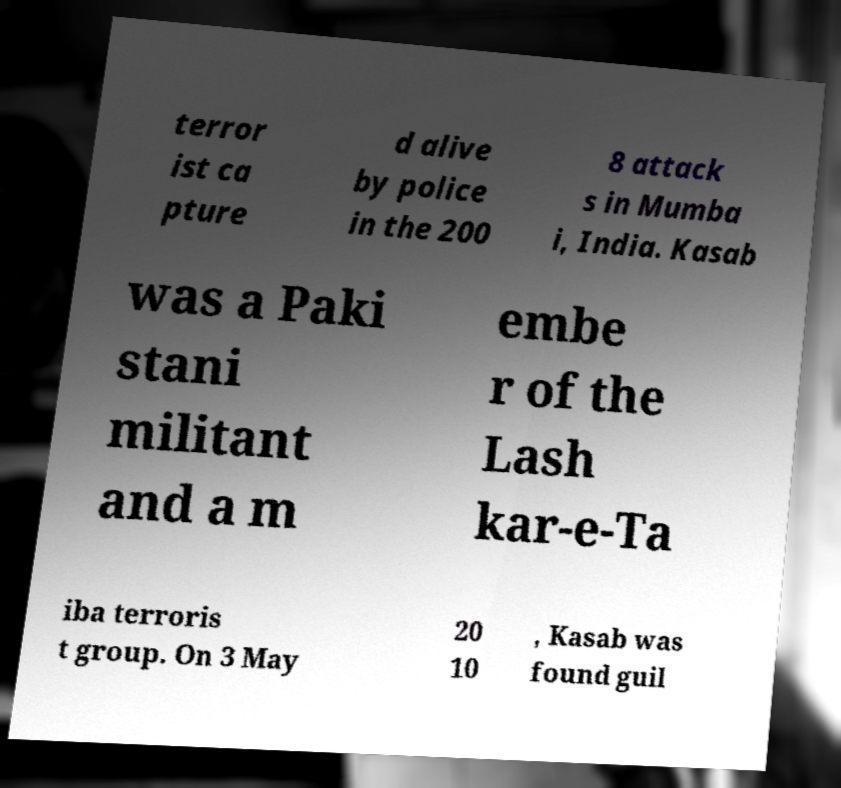There's text embedded in this image that I need extracted. Can you transcribe it verbatim? terror ist ca pture d alive by police in the 200 8 attack s in Mumba i, India. Kasab was a Paki stani militant and a m embe r of the Lash kar-e-Ta iba terroris t group. On 3 May 20 10 , Kasab was found guil 